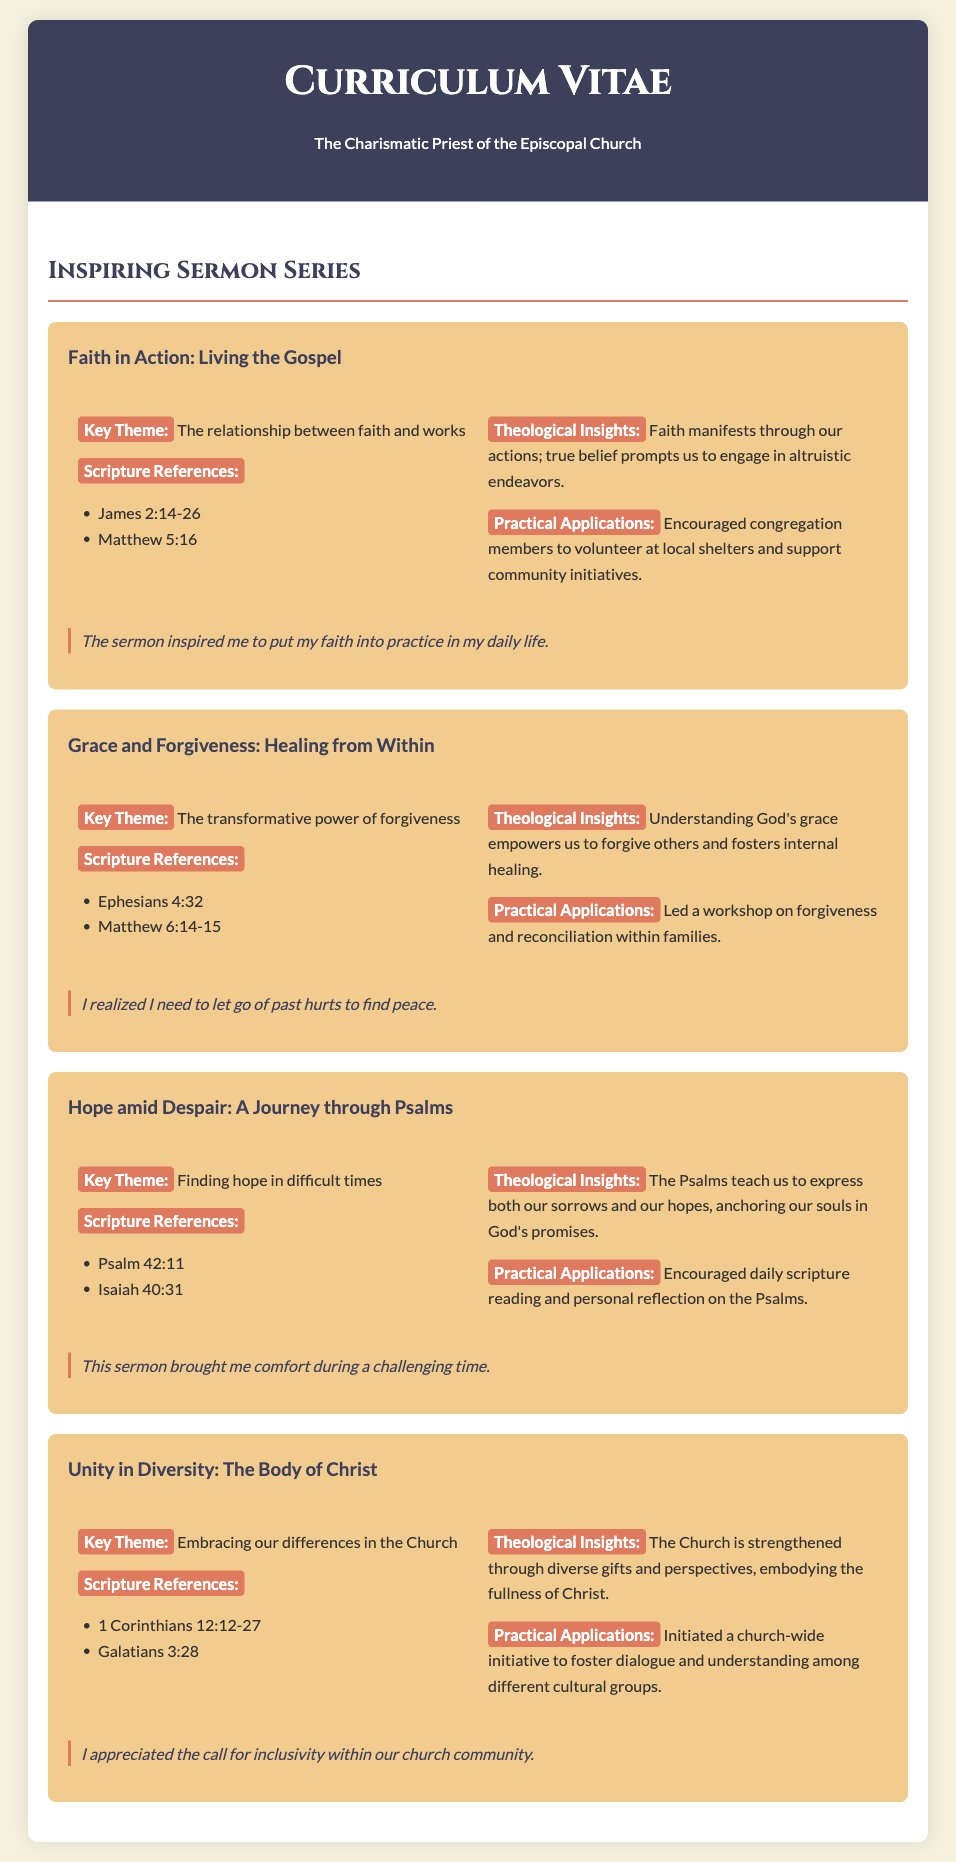what is the title of the first sermon? The title of the first sermon is the first sermon listed in the document, which is "Faith in Action: Living the Gospel".
Answer: Faith in Action: Living the Gospel what is the key theme of the sermon "Grace and Forgiveness: Healing from Within"? The key theme is specified in the document under that sermon, which is "The transformative power of forgiveness."
Answer: The transformative power of forgiveness how many scripture references are provided for the "Hope amid Despair: A Journey through Psalms"? The document lists scripture references for this sermon, specifically counting two references: Psalm 42:11 and Isaiah 40:31.
Answer: 2 what practical application was encouraged in the sermon "Unity in Diversity: The Body of Christ"? The document describes a specific practical application initiated in this sermon regarding church-wide initiatives for dialogue, making it clear what was encouraged.
Answer: Initiated a church-wide initiative to foster dialogue and understanding among different cultural groups which scripture reference is associated with the theme of faith and works? The document provides specific scripture references related to the first sermon, including one that directly connects to the theme of faith and works.
Answer: James 2:14-26 